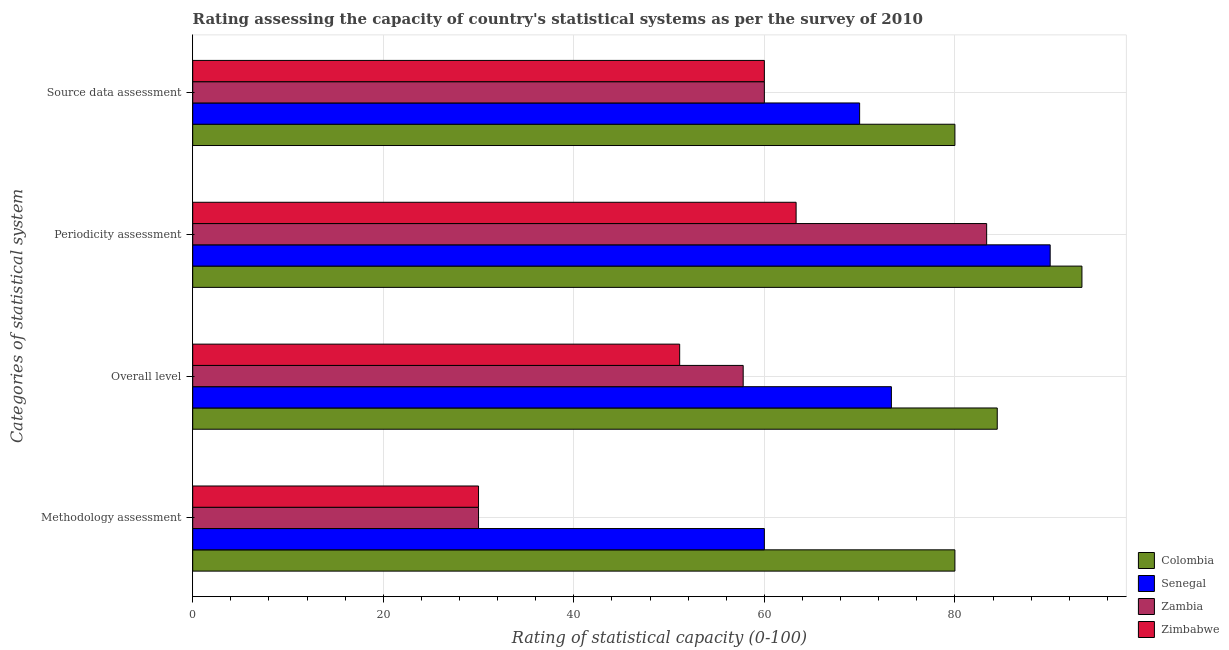How many bars are there on the 2nd tick from the top?
Make the answer very short. 4. How many bars are there on the 4th tick from the bottom?
Your response must be concise. 4. What is the label of the 4th group of bars from the top?
Offer a terse response. Methodology assessment. What is the overall level rating in Senegal?
Provide a succinct answer. 73.33. Across all countries, what is the minimum periodicity assessment rating?
Your answer should be compact. 63.33. In which country was the periodicity assessment rating maximum?
Ensure brevity in your answer.  Colombia. In which country was the methodology assessment rating minimum?
Your answer should be compact. Zambia. What is the total periodicity assessment rating in the graph?
Offer a terse response. 330. What is the difference between the overall level rating in Senegal and that in Colombia?
Ensure brevity in your answer.  -11.11. What is the difference between the periodicity assessment rating in Zambia and the methodology assessment rating in Zimbabwe?
Keep it short and to the point. 53.33. What is the average source data assessment rating per country?
Keep it short and to the point. 67.5. What is the difference between the methodology assessment rating and periodicity assessment rating in Zimbabwe?
Keep it short and to the point. -33.33. In how many countries, is the overall level rating greater than 88 ?
Ensure brevity in your answer.  0. What is the ratio of the overall level rating in Zambia to that in Colombia?
Your answer should be very brief. 0.68. Is the methodology assessment rating in Colombia less than that in Zambia?
Keep it short and to the point. No. What is the difference between the highest and the second highest methodology assessment rating?
Ensure brevity in your answer.  20. In how many countries, is the source data assessment rating greater than the average source data assessment rating taken over all countries?
Your answer should be very brief. 2. Is the sum of the periodicity assessment rating in Zimbabwe and Colombia greater than the maximum source data assessment rating across all countries?
Your response must be concise. Yes. What does the 2nd bar from the top in Overall level represents?
Provide a short and direct response. Zambia. Are all the bars in the graph horizontal?
Provide a succinct answer. Yes. Does the graph contain grids?
Ensure brevity in your answer.  Yes. How are the legend labels stacked?
Ensure brevity in your answer.  Vertical. What is the title of the graph?
Provide a short and direct response. Rating assessing the capacity of country's statistical systems as per the survey of 2010 . Does "Kyrgyz Republic" appear as one of the legend labels in the graph?
Make the answer very short. No. What is the label or title of the X-axis?
Keep it short and to the point. Rating of statistical capacity (0-100). What is the label or title of the Y-axis?
Ensure brevity in your answer.  Categories of statistical system. What is the Rating of statistical capacity (0-100) in Zimbabwe in Methodology assessment?
Provide a succinct answer. 30. What is the Rating of statistical capacity (0-100) of Colombia in Overall level?
Ensure brevity in your answer.  84.44. What is the Rating of statistical capacity (0-100) of Senegal in Overall level?
Provide a short and direct response. 73.33. What is the Rating of statistical capacity (0-100) of Zambia in Overall level?
Keep it short and to the point. 57.78. What is the Rating of statistical capacity (0-100) of Zimbabwe in Overall level?
Provide a succinct answer. 51.11. What is the Rating of statistical capacity (0-100) of Colombia in Periodicity assessment?
Offer a very short reply. 93.33. What is the Rating of statistical capacity (0-100) in Senegal in Periodicity assessment?
Give a very brief answer. 90. What is the Rating of statistical capacity (0-100) in Zambia in Periodicity assessment?
Your response must be concise. 83.33. What is the Rating of statistical capacity (0-100) of Zimbabwe in Periodicity assessment?
Offer a terse response. 63.33. What is the Rating of statistical capacity (0-100) of Senegal in Source data assessment?
Offer a very short reply. 70. Across all Categories of statistical system, what is the maximum Rating of statistical capacity (0-100) in Colombia?
Your answer should be very brief. 93.33. Across all Categories of statistical system, what is the maximum Rating of statistical capacity (0-100) in Senegal?
Offer a very short reply. 90. Across all Categories of statistical system, what is the maximum Rating of statistical capacity (0-100) in Zambia?
Give a very brief answer. 83.33. Across all Categories of statistical system, what is the maximum Rating of statistical capacity (0-100) of Zimbabwe?
Make the answer very short. 63.33. Across all Categories of statistical system, what is the minimum Rating of statistical capacity (0-100) in Colombia?
Provide a succinct answer. 80. Across all Categories of statistical system, what is the minimum Rating of statistical capacity (0-100) of Zambia?
Your response must be concise. 30. What is the total Rating of statistical capacity (0-100) in Colombia in the graph?
Keep it short and to the point. 337.78. What is the total Rating of statistical capacity (0-100) in Senegal in the graph?
Your answer should be compact. 293.33. What is the total Rating of statistical capacity (0-100) in Zambia in the graph?
Ensure brevity in your answer.  231.11. What is the total Rating of statistical capacity (0-100) of Zimbabwe in the graph?
Keep it short and to the point. 204.44. What is the difference between the Rating of statistical capacity (0-100) of Colombia in Methodology assessment and that in Overall level?
Your response must be concise. -4.44. What is the difference between the Rating of statistical capacity (0-100) of Senegal in Methodology assessment and that in Overall level?
Ensure brevity in your answer.  -13.33. What is the difference between the Rating of statistical capacity (0-100) of Zambia in Methodology assessment and that in Overall level?
Your answer should be very brief. -27.78. What is the difference between the Rating of statistical capacity (0-100) of Zimbabwe in Methodology assessment and that in Overall level?
Your answer should be very brief. -21.11. What is the difference between the Rating of statistical capacity (0-100) in Colombia in Methodology assessment and that in Periodicity assessment?
Make the answer very short. -13.33. What is the difference between the Rating of statistical capacity (0-100) in Zambia in Methodology assessment and that in Periodicity assessment?
Your response must be concise. -53.33. What is the difference between the Rating of statistical capacity (0-100) in Zimbabwe in Methodology assessment and that in Periodicity assessment?
Keep it short and to the point. -33.33. What is the difference between the Rating of statistical capacity (0-100) in Zambia in Methodology assessment and that in Source data assessment?
Offer a very short reply. -30. What is the difference between the Rating of statistical capacity (0-100) in Colombia in Overall level and that in Periodicity assessment?
Offer a terse response. -8.89. What is the difference between the Rating of statistical capacity (0-100) of Senegal in Overall level and that in Periodicity assessment?
Provide a succinct answer. -16.67. What is the difference between the Rating of statistical capacity (0-100) of Zambia in Overall level and that in Periodicity assessment?
Ensure brevity in your answer.  -25.56. What is the difference between the Rating of statistical capacity (0-100) of Zimbabwe in Overall level and that in Periodicity assessment?
Your response must be concise. -12.22. What is the difference between the Rating of statistical capacity (0-100) in Colombia in Overall level and that in Source data assessment?
Keep it short and to the point. 4.44. What is the difference between the Rating of statistical capacity (0-100) in Senegal in Overall level and that in Source data assessment?
Your response must be concise. 3.33. What is the difference between the Rating of statistical capacity (0-100) of Zambia in Overall level and that in Source data assessment?
Your response must be concise. -2.22. What is the difference between the Rating of statistical capacity (0-100) in Zimbabwe in Overall level and that in Source data assessment?
Give a very brief answer. -8.89. What is the difference between the Rating of statistical capacity (0-100) of Colombia in Periodicity assessment and that in Source data assessment?
Keep it short and to the point. 13.33. What is the difference between the Rating of statistical capacity (0-100) in Zambia in Periodicity assessment and that in Source data assessment?
Your answer should be very brief. 23.33. What is the difference between the Rating of statistical capacity (0-100) of Zimbabwe in Periodicity assessment and that in Source data assessment?
Provide a short and direct response. 3.33. What is the difference between the Rating of statistical capacity (0-100) in Colombia in Methodology assessment and the Rating of statistical capacity (0-100) in Zambia in Overall level?
Provide a short and direct response. 22.22. What is the difference between the Rating of statistical capacity (0-100) in Colombia in Methodology assessment and the Rating of statistical capacity (0-100) in Zimbabwe in Overall level?
Offer a very short reply. 28.89. What is the difference between the Rating of statistical capacity (0-100) of Senegal in Methodology assessment and the Rating of statistical capacity (0-100) of Zambia in Overall level?
Keep it short and to the point. 2.22. What is the difference between the Rating of statistical capacity (0-100) in Senegal in Methodology assessment and the Rating of statistical capacity (0-100) in Zimbabwe in Overall level?
Your response must be concise. 8.89. What is the difference between the Rating of statistical capacity (0-100) in Zambia in Methodology assessment and the Rating of statistical capacity (0-100) in Zimbabwe in Overall level?
Keep it short and to the point. -21.11. What is the difference between the Rating of statistical capacity (0-100) of Colombia in Methodology assessment and the Rating of statistical capacity (0-100) of Senegal in Periodicity assessment?
Make the answer very short. -10. What is the difference between the Rating of statistical capacity (0-100) of Colombia in Methodology assessment and the Rating of statistical capacity (0-100) of Zambia in Periodicity assessment?
Keep it short and to the point. -3.33. What is the difference between the Rating of statistical capacity (0-100) in Colombia in Methodology assessment and the Rating of statistical capacity (0-100) in Zimbabwe in Periodicity assessment?
Make the answer very short. 16.67. What is the difference between the Rating of statistical capacity (0-100) of Senegal in Methodology assessment and the Rating of statistical capacity (0-100) of Zambia in Periodicity assessment?
Your answer should be compact. -23.33. What is the difference between the Rating of statistical capacity (0-100) in Senegal in Methodology assessment and the Rating of statistical capacity (0-100) in Zimbabwe in Periodicity assessment?
Your response must be concise. -3.33. What is the difference between the Rating of statistical capacity (0-100) in Zambia in Methodology assessment and the Rating of statistical capacity (0-100) in Zimbabwe in Periodicity assessment?
Provide a succinct answer. -33.33. What is the difference between the Rating of statistical capacity (0-100) of Colombia in Methodology assessment and the Rating of statistical capacity (0-100) of Senegal in Source data assessment?
Your answer should be compact. 10. What is the difference between the Rating of statistical capacity (0-100) in Colombia in Methodology assessment and the Rating of statistical capacity (0-100) in Zambia in Source data assessment?
Offer a very short reply. 20. What is the difference between the Rating of statistical capacity (0-100) in Colombia in Methodology assessment and the Rating of statistical capacity (0-100) in Zimbabwe in Source data assessment?
Offer a terse response. 20. What is the difference between the Rating of statistical capacity (0-100) of Senegal in Methodology assessment and the Rating of statistical capacity (0-100) of Zambia in Source data assessment?
Offer a very short reply. 0. What is the difference between the Rating of statistical capacity (0-100) of Zambia in Methodology assessment and the Rating of statistical capacity (0-100) of Zimbabwe in Source data assessment?
Give a very brief answer. -30. What is the difference between the Rating of statistical capacity (0-100) of Colombia in Overall level and the Rating of statistical capacity (0-100) of Senegal in Periodicity assessment?
Offer a terse response. -5.56. What is the difference between the Rating of statistical capacity (0-100) in Colombia in Overall level and the Rating of statistical capacity (0-100) in Zambia in Periodicity assessment?
Provide a short and direct response. 1.11. What is the difference between the Rating of statistical capacity (0-100) in Colombia in Overall level and the Rating of statistical capacity (0-100) in Zimbabwe in Periodicity assessment?
Your answer should be compact. 21.11. What is the difference between the Rating of statistical capacity (0-100) in Zambia in Overall level and the Rating of statistical capacity (0-100) in Zimbabwe in Periodicity assessment?
Your answer should be compact. -5.56. What is the difference between the Rating of statistical capacity (0-100) in Colombia in Overall level and the Rating of statistical capacity (0-100) in Senegal in Source data assessment?
Provide a short and direct response. 14.44. What is the difference between the Rating of statistical capacity (0-100) in Colombia in Overall level and the Rating of statistical capacity (0-100) in Zambia in Source data assessment?
Offer a terse response. 24.44. What is the difference between the Rating of statistical capacity (0-100) of Colombia in Overall level and the Rating of statistical capacity (0-100) of Zimbabwe in Source data assessment?
Provide a short and direct response. 24.44. What is the difference between the Rating of statistical capacity (0-100) of Senegal in Overall level and the Rating of statistical capacity (0-100) of Zambia in Source data assessment?
Your answer should be very brief. 13.33. What is the difference between the Rating of statistical capacity (0-100) of Senegal in Overall level and the Rating of statistical capacity (0-100) of Zimbabwe in Source data assessment?
Your response must be concise. 13.33. What is the difference between the Rating of statistical capacity (0-100) of Zambia in Overall level and the Rating of statistical capacity (0-100) of Zimbabwe in Source data assessment?
Offer a very short reply. -2.22. What is the difference between the Rating of statistical capacity (0-100) in Colombia in Periodicity assessment and the Rating of statistical capacity (0-100) in Senegal in Source data assessment?
Your answer should be very brief. 23.33. What is the difference between the Rating of statistical capacity (0-100) of Colombia in Periodicity assessment and the Rating of statistical capacity (0-100) of Zambia in Source data assessment?
Your response must be concise. 33.33. What is the difference between the Rating of statistical capacity (0-100) of Colombia in Periodicity assessment and the Rating of statistical capacity (0-100) of Zimbabwe in Source data assessment?
Give a very brief answer. 33.33. What is the difference between the Rating of statistical capacity (0-100) of Senegal in Periodicity assessment and the Rating of statistical capacity (0-100) of Zambia in Source data assessment?
Provide a short and direct response. 30. What is the difference between the Rating of statistical capacity (0-100) in Senegal in Periodicity assessment and the Rating of statistical capacity (0-100) in Zimbabwe in Source data assessment?
Your answer should be very brief. 30. What is the difference between the Rating of statistical capacity (0-100) of Zambia in Periodicity assessment and the Rating of statistical capacity (0-100) of Zimbabwe in Source data assessment?
Your answer should be very brief. 23.33. What is the average Rating of statistical capacity (0-100) of Colombia per Categories of statistical system?
Keep it short and to the point. 84.44. What is the average Rating of statistical capacity (0-100) of Senegal per Categories of statistical system?
Provide a short and direct response. 73.33. What is the average Rating of statistical capacity (0-100) in Zambia per Categories of statistical system?
Offer a terse response. 57.78. What is the average Rating of statistical capacity (0-100) of Zimbabwe per Categories of statistical system?
Make the answer very short. 51.11. What is the difference between the Rating of statistical capacity (0-100) in Colombia and Rating of statistical capacity (0-100) in Senegal in Methodology assessment?
Your answer should be very brief. 20. What is the difference between the Rating of statistical capacity (0-100) of Colombia and Rating of statistical capacity (0-100) of Zambia in Methodology assessment?
Give a very brief answer. 50. What is the difference between the Rating of statistical capacity (0-100) in Senegal and Rating of statistical capacity (0-100) in Zambia in Methodology assessment?
Ensure brevity in your answer.  30. What is the difference between the Rating of statistical capacity (0-100) in Senegal and Rating of statistical capacity (0-100) in Zimbabwe in Methodology assessment?
Offer a terse response. 30. What is the difference between the Rating of statistical capacity (0-100) of Zambia and Rating of statistical capacity (0-100) of Zimbabwe in Methodology assessment?
Your answer should be very brief. 0. What is the difference between the Rating of statistical capacity (0-100) of Colombia and Rating of statistical capacity (0-100) of Senegal in Overall level?
Your answer should be compact. 11.11. What is the difference between the Rating of statistical capacity (0-100) in Colombia and Rating of statistical capacity (0-100) in Zambia in Overall level?
Offer a very short reply. 26.67. What is the difference between the Rating of statistical capacity (0-100) of Colombia and Rating of statistical capacity (0-100) of Zimbabwe in Overall level?
Make the answer very short. 33.33. What is the difference between the Rating of statistical capacity (0-100) in Senegal and Rating of statistical capacity (0-100) in Zambia in Overall level?
Give a very brief answer. 15.56. What is the difference between the Rating of statistical capacity (0-100) of Senegal and Rating of statistical capacity (0-100) of Zimbabwe in Overall level?
Your response must be concise. 22.22. What is the difference between the Rating of statistical capacity (0-100) in Colombia and Rating of statistical capacity (0-100) in Zambia in Periodicity assessment?
Your answer should be compact. 10. What is the difference between the Rating of statistical capacity (0-100) of Senegal and Rating of statistical capacity (0-100) of Zambia in Periodicity assessment?
Your answer should be compact. 6.67. What is the difference between the Rating of statistical capacity (0-100) in Senegal and Rating of statistical capacity (0-100) in Zimbabwe in Periodicity assessment?
Your response must be concise. 26.67. What is the difference between the Rating of statistical capacity (0-100) in Colombia and Rating of statistical capacity (0-100) in Zambia in Source data assessment?
Ensure brevity in your answer.  20. What is the difference between the Rating of statistical capacity (0-100) of Senegal and Rating of statistical capacity (0-100) of Zambia in Source data assessment?
Give a very brief answer. 10. What is the difference between the Rating of statistical capacity (0-100) of Zambia and Rating of statistical capacity (0-100) of Zimbabwe in Source data assessment?
Make the answer very short. 0. What is the ratio of the Rating of statistical capacity (0-100) of Senegal in Methodology assessment to that in Overall level?
Offer a terse response. 0.82. What is the ratio of the Rating of statistical capacity (0-100) in Zambia in Methodology assessment to that in Overall level?
Provide a succinct answer. 0.52. What is the ratio of the Rating of statistical capacity (0-100) of Zimbabwe in Methodology assessment to that in Overall level?
Your answer should be compact. 0.59. What is the ratio of the Rating of statistical capacity (0-100) of Colombia in Methodology assessment to that in Periodicity assessment?
Ensure brevity in your answer.  0.86. What is the ratio of the Rating of statistical capacity (0-100) in Senegal in Methodology assessment to that in Periodicity assessment?
Offer a terse response. 0.67. What is the ratio of the Rating of statistical capacity (0-100) of Zambia in Methodology assessment to that in Periodicity assessment?
Make the answer very short. 0.36. What is the ratio of the Rating of statistical capacity (0-100) in Zimbabwe in Methodology assessment to that in Periodicity assessment?
Provide a short and direct response. 0.47. What is the ratio of the Rating of statistical capacity (0-100) in Colombia in Methodology assessment to that in Source data assessment?
Ensure brevity in your answer.  1. What is the ratio of the Rating of statistical capacity (0-100) in Zimbabwe in Methodology assessment to that in Source data assessment?
Ensure brevity in your answer.  0.5. What is the ratio of the Rating of statistical capacity (0-100) of Colombia in Overall level to that in Periodicity assessment?
Provide a short and direct response. 0.9. What is the ratio of the Rating of statistical capacity (0-100) in Senegal in Overall level to that in Periodicity assessment?
Keep it short and to the point. 0.81. What is the ratio of the Rating of statistical capacity (0-100) of Zambia in Overall level to that in Periodicity assessment?
Offer a terse response. 0.69. What is the ratio of the Rating of statistical capacity (0-100) of Zimbabwe in Overall level to that in Periodicity assessment?
Provide a succinct answer. 0.81. What is the ratio of the Rating of statistical capacity (0-100) of Colombia in Overall level to that in Source data assessment?
Keep it short and to the point. 1.06. What is the ratio of the Rating of statistical capacity (0-100) of Senegal in Overall level to that in Source data assessment?
Make the answer very short. 1.05. What is the ratio of the Rating of statistical capacity (0-100) of Zambia in Overall level to that in Source data assessment?
Your answer should be very brief. 0.96. What is the ratio of the Rating of statistical capacity (0-100) of Zimbabwe in Overall level to that in Source data assessment?
Ensure brevity in your answer.  0.85. What is the ratio of the Rating of statistical capacity (0-100) in Colombia in Periodicity assessment to that in Source data assessment?
Offer a very short reply. 1.17. What is the ratio of the Rating of statistical capacity (0-100) in Senegal in Periodicity assessment to that in Source data assessment?
Provide a short and direct response. 1.29. What is the ratio of the Rating of statistical capacity (0-100) in Zambia in Periodicity assessment to that in Source data assessment?
Ensure brevity in your answer.  1.39. What is the ratio of the Rating of statistical capacity (0-100) in Zimbabwe in Periodicity assessment to that in Source data assessment?
Provide a succinct answer. 1.06. What is the difference between the highest and the second highest Rating of statistical capacity (0-100) of Colombia?
Provide a short and direct response. 8.89. What is the difference between the highest and the second highest Rating of statistical capacity (0-100) in Senegal?
Offer a terse response. 16.67. What is the difference between the highest and the second highest Rating of statistical capacity (0-100) of Zambia?
Your answer should be very brief. 23.33. What is the difference between the highest and the second highest Rating of statistical capacity (0-100) of Zimbabwe?
Offer a terse response. 3.33. What is the difference between the highest and the lowest Rating of statistical capacity (0-100) in Colombia?
Make the answer very short. 13.33. What is the difference between the highest and the lowest Rating of statistical capacity (0-100) of Senegal?
Provide a short and direct response. 30. What is the difference between the highest and the lowest Rating of statistical capacity (0-100) of Zambia?
Your answer should be very brief. 53.33. What is the difference between the highest and the lowest Rating of statistical capacity (0-100) of Zimbabwe?
Offer a very short reply. 33.33. 